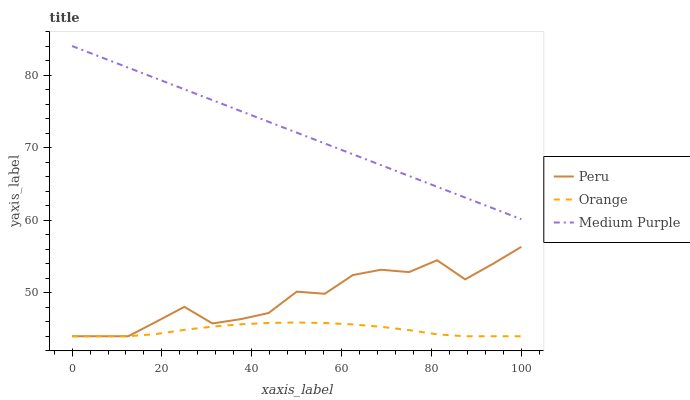Does Orange have the minimum area under the curve?
Answer yes or no. Yes. Does Medium Purple have the maximum area under the curve?
Answer yes or no. Yes. Does Peru have the minimum area under the curve?
Answer yes or no. No. Does Peru have the maximum area under the curve?
Answer yes or no. No. Is Medium Purple the smoothest?
Answer yes or no. Yes. Is Peru the roughest?
Answer yes or no. Yes. Is Peru the smoothest?
Answer yes or no. No. Is Medium Purple the roughest?
Answer yes or no. No. Does Medium Purple have the lowest value?
Answer yes or no. No. Does Medium Purple have the highest value?
Answer yes or no. Yes. Does Peru have the highest value?
Answer yes or no. No. Is Peru less than Medium Purple?
Answer yes or no. Yes. Is Medium Purple greater than Orange?
Answer yes or no. Yes. Does Peru intersect Orange?
Answer yes or no. Yes. Is Peru less than Orange?
Answer yes or no. No. Is Peru greater than Orange?
Answer yes or no. No. Does Peru intersect Medium Purple?
Answer yes or no. No. 